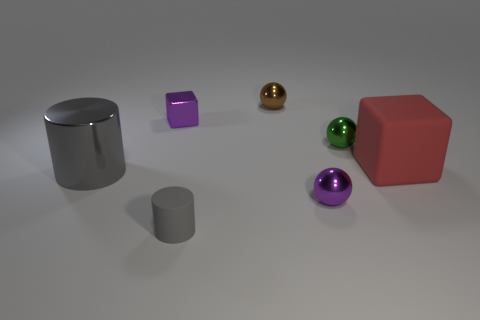How many cubes are in front of the small green ball and left of the red rubber object?
Offer a very short reply. 0. How many small red cylinders are made of the same material as the green object?
Give a very brief answer. 0. There is a cube that is the same material as the small gray thing; what color is it?
Your answer should be compact. Red. Is the number of tiny brown metal objects less than the number of tiny things?
Provide a succinct answer. Yes. The cylinder that is to the left of the purple shiny object that is left of the tiny purple object that is on the right side of the small rubber cylinder is made of what material?
Provide a short and direct response. Metal. What is the material of the green ball?
Your answer should be compact. Metal. There is a matte object that is to the left of the large matte block; does it have the same color as the cylinder left of the tiny gray rubber cylinder?
Offer a terse response. Yes. Are there more green things than shiny things?
Your answer should be compact. No. What number of large metal objects are the same color as the tiny cylinder?
Your answer should be compact. 1. There is another metal object that is the same shape as the small gray thing; what color is it?
Your answer should be very brief. Gray. 